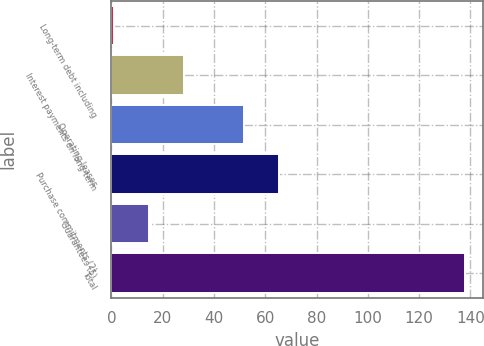<chart> <loc_0><loc_0><loc_500><loc_500><bar_chart><fcel>Long-term debt including<fcel>Interest payments on long-term<fcel>Operating leases<fcel>Purchase commitments (2)<fcel>Guarantees (5)<fcel>Total<nl><fcel>1.1<fcel>28.46<fcel>51.8<fcel>65.48<fcel>14.78<fcel>137.9<nl></chart> 